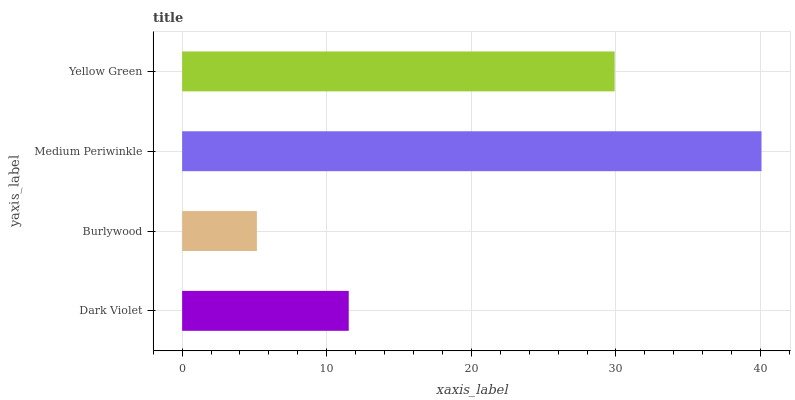Is Burlywood the minimum?
Answer yes or no. Yes. Is Medium Periwinkle the maximum?
Answer yes or no. Yes. Is Medium Periwinkle the minimum?
Answer yes or no. No. Is Burlywood the maximum?
Answer yes or no. No. Is Medium Periwinkle greater than Burlywood?
Answer yes or no. Yes. Is Burlywood less than Medium Periwinkle?
Answer yes or no. Yes. Is Burlywood greater than Medium Periwinkle?
Answer yes or no. No. Is Medium Periwinkle less than Burlywood?
Answer yes or no. No. Is Yellow Green the high median?
Answer yes or no. Yes. Is Dark Violet the low median?
Answer yes or no. Yes. Is Medium Periwinkle the high median?
Answer yes or no. No. Is Yellow Green the low median?
Answer yes or no. No. 